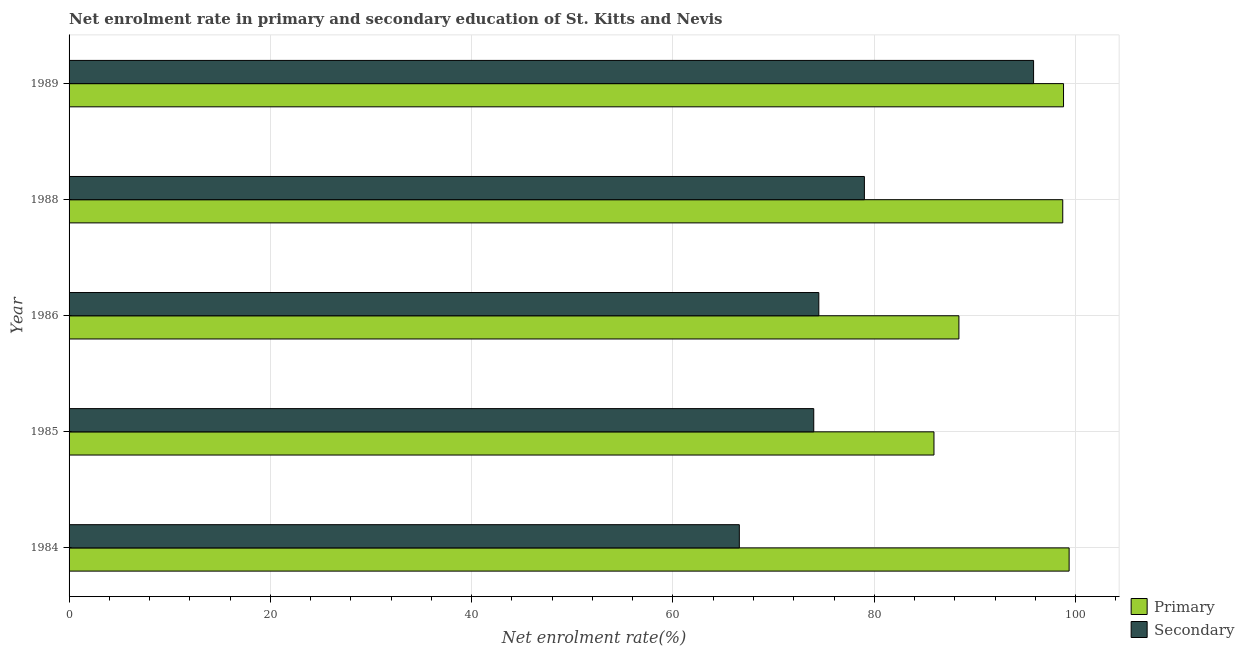How many groups of bars are there?
Offer a terse response. 5. Are the number of bars per tick equal to the number of legend labels?
Offer a very short reply. Yes. Are the number of bars on each tick of the Y-axis equal?
Provide a short and direct response. Yes. How many bars are there on the 2nd tick from the top?
Your response must be concise. 2. In how many cases, is the number of bars for a given year not equal to the number of legend labels?
Your response must be concise. 0. What is the enrollment rate in secondary education in 1986?
Your response must be concise. 74.49. Across all years, what is the maximum enrollment rate in primary education?
Make the answer very short. 99.36. Across all years, what is the minimum enrollment rate in primary education?
Keep it short and to the point. 85.93. What is the total enrollment rate in primary education in the graph?
Your answer should be compact. 471.24. What is the difference between the enrollment rate in secondary education in 1985 and that in 1986?
Provide a succinct answer. -0.5. What is the difference between the enrollment rate in primary education in 1985 and the enrollment rate in secondary education in 1989?
Provide a succinct answer. -9.9. What is the average enrollment rate in secondary education per year?
Offer a very short reply. 77.98. In the year 1984, what is the difference between the enrollment rate in primary education and enrollment rate in secondary education?
Offer a terse response. 32.77. In how many years, is the enrollment rate in secondary education greater than 32 %?
Your response must be concise. 5. What is the ratio of the enrollment rate in secondary education in 1986 to that in 1989?
Your response must be concise. 0.78. Is the enrollment rate in primary education in 1986 less than that in 1988?
Make the answer very short. Yes. Is the difference between the enrollment rate in secondary education in 1984 and 1988 greater than the difference between the enrollment rate in primary education in 1984 and 1988?
Your response must be concise. No. What is the difference between the highest and the second highest enrollment rate in secondary education?
Provide a short and direct response. 16.81. What is the difference between the highest and the lowest enrollment rate in secondary education?
Offer a very short reply. 29.24. In how many years, is the enrollment rate in secondary education greater than the average enrollment rate in secondary education taken over all years?
Your answer should be very brief. 2. What does the 2nd bar from the top in 1989 represents?
Make the answer very short. Primary. What does the 2nd bar from the bottom in 1989 represents?
Provide a succinct answer. Secondary. How many bars are there?
Ensure brevity in your answer.  10. Are all the bars in the graph horizontal?
Offer a terse response. Yes. How many years are there in the graph?
Provide a succinct answer. 5. Does the graph contain any zero values?
Provide a short and direct response. No. Does the graph contain grids?
Offer a very short reply. Yes. How many legend labels are there?
Provide a short and direct response. 2. What is the title of the graph?
Keep it short and to the point. Net enrolment rate in primary and secondary education of St. Kitts and Nevis. Does "Under-5(female)" appear as one of the legend labels in the graph?
Your answer should be very brief. No. What is the label or title of the X-axis?
Provide a succinct answer. Net enrolment rate(%). What is the label or title of the Y-axis?
Provide a succinct answer. Year. What is the Net enrolment rate(%) in Primary in 1984?
Ensure brevity in your answer.  99.36. What is the Net enrolment rate(%) of Secondary in 1984?
Give a very brief answer. 66.59. What is the Net enrolment rate(%) of Primary in 1985?
Your answer should be compact. 85.93. What is the Net enrolment rate(%) in Secondary in 1985?
Offer a terse response. 73.99. What is the Net enrolment rate(%) in Primary in 1986?
Offer a very short reply. 88.41. What is the Net enrolment rate(%) in Secondary in 1986?
Make the answer very short. 74.49. What is the Net enrolment rate(%) in Primary in 1988?
Provide a succinct answer. 98.73. What is the Net enrolment rate(%) in Secondary in 1988?
Give a very brief answer. 79.02. What is the Net enrolment rate(%) in Primary in 1989?
Ensure brevity in your answer.  98.81. What is the Net enrolment rate(%) in Secondary in 1989?
Give a very brief answer. 95.83. Across all years, what is the maximum Net enrolment rate(%) in Primary?
Give a very brief answer. 99.36. Across all years, what is the maximum Net enrolment rate(%) of Secondary?
Offer a very short reply. 95.83. Across all years, what is the minimum Net enrolment rate(%) in Primary?
Keep it short and to the point. 85.93. Across all years, what is the minimum Net enrolment rate(%) in Secondary?
Ensure brevity in your answer.  66.59. What is the total Net enrolment rate(%) in Primary in the graph?
Your answer should be compact. 471.24. What is the total Net enrolment rate(%) in Secondary in the graph?
Keep it short and to the point. 389.92. What is the difference between the Net enrolment rate(%) of Primary in 1984 and that in 1985?
Make the answer very short. 13.43. What is the difference between the Net enrolment rate(%) in Secondary in 1984 and that in 1985?
Give a very brief answer. -7.39. What is the difference between the Net enrolment rate(%) of Primary in 1984 and that in 1986?
Keep it short and to the point. 10.95. What is the difference between the Net enrolment rate(%) of Secondary in 1984 and that in 1986?
Keep it short and to the point. -7.9. What is the difference between the Net enrolment rate(%) of Primary in 1984 and that in 1988?
Keep it short and to the point. 0.63. What is the difference between the Net enrolment rate(%) in Secondary in 1984 and that in 1988?
Ensure brevity in your answer.  -12.43. What is the difference between the Net enrolment rate(%) in Primary in 1984 and that in 1989?
Make the answer very short. 0.56. What is the difference between the Net enrolment rate(%) of Secondary in 1984 and that in 1989?
Your answer should be very brief. -29.24. What is the difference between the Net enrolment rate(%) in Primary in 1985 and that in 1986?
Ensure brevity in your answer.  -2.48. What is the difference between the Net enrolment rate(%) of Secondary in 1985 and that in 1986?
Your answer should be compact. -0.5. What is the difference between the Net enrolment rate(%) of Primary in 1985 and that in 1988?
Offer a very short reply. -12.79. What is the difference between the Net enrolment rate(%) of Secondary in 1985 and that in 1988?
Provide a succinct answer. -5.03. What is the difference between the Net enrolment rate(%) in Primary in 1985 and that in 1989?
Make the answer very short. -12.87. What is the difference between the Net enrolment rate(%) of Secondary in 1985 and that in 1989?
Keep it short and to the point. -21.84. What is the difference between the Net enrolment rate(%) in Primary in 1986 and that in 1988?
Your answer should be very brief. -10.32. What is the difference between the Net enrolment rate(%) of Secondary in 1986 and that in 1988?
Keep it short and to the point. -4.53. What is the difference between the Net enrolment rate(%) of Primary in 1986 and that in 1989?
Offer a terse response. -10.4. What is the difference between the Net enrolment rate(%) of Secondary in 1986 and that in 1989?
Offer a very short reply. -21.34. What is the difference between the Net enrolment rate(%) of Primary in 1988 and that in 1989?
Your response must be concise. -0.08. What is the difference between the Net enrolment rate(%) of Secondary in 1988 and that in 1989?
Make the answer very short. -16.81. What is the difference between the Net enrolment rate(%) of Primary in 1984 and the Net enrolment rate(%) of Secondary in 1985?
Offer a terse response. 25.37. What is the difference between the Net enrolment rate(%) of Primary in 1984 and the Net enrolment rate(%) of Secondary in 1986?
Your response must be concise. 24.87. What is the difference between the Net enrolment rate(%) of Primary in 1984 and the Net enrolment rate(%) of Secondary in 1988?
Provide a succinct answer. 20.34. What is the difference between the Net enrolment rate(%) in Primary in 1984 and the Net enrolment rate(%) in Secondary in 1989?
Make the answer very short. 3.53. What is the difference between the Net enrolment rate(%) of Primary in 1985 and the Net enrolment rate(%) of Secondary in 1986?
Your response must be concise. 11.44. What is the difference between the Net enrolment rate(%) of Primary in 1985 and the Net enrolment rate(%) of Secondary in 1988?
Your answer should be very brief. 6.91. What is the difference between the Net enrolment rate(%) of Primary in 1985 and the Net enrolment rate(%) of Secondary in 1989?
Your answer should be very brief. -9.9. What is the difference between the Net enrolment rate(%) of Primary in 1986 and the Net enrolment rate(%) of Secondary in 1988?
Ensure brevity in your answer.  9.39. What is the difference between the Net enrolment rate(%) of Primary in 1986 and the Net enrolment rate(%) of Secondary in 1989?
Ensure brevity in your answer.  -7.42. What is the difference between the Net enrolment rate(%) of Primary in 1988 and the Net enrolment rate(%) of Secondary in 1989?
Ensure brevity in your answer.  2.9. What is the average Net enrolment rate(%) of Primary per year?
Offer a terse response. 94.25. What is the average Net enrolment rate(%) of Secondary per year?
Give a very brief answer. 77.98. In the year 1984, what is the difference between the Net enrolment rate(%) in Primary and Net enrolment rate(%) in Secondary?
Make the answer very short. 32.77. In the year 1985, what is the difference between the Net enrolment rate(%) of Primary and Net enrolment rate(%) of Secondary?
Your answer should be compact. 11.94. In the year 1986, what is the difference between the Net enrolment rate(%) of Primary and Net enrolment rate(%) of Secondary?
Your answer should be very brief. 13.92. In the year 1988, what is the difference between the Net enrolment rate(%) in Primary and Net enrolment rate(%) in Secondary?
Give a very brief answer. 19.71. In the year 1989, what is the difference between the Net enrolment rate(%) of Primary and Net enrolment rate(%) of Secondary?
Make the answer very short. 2.98. What is the ratio of the Net enrolment rate(%) in Primary in 1984 to that in 1985?
Make the answer very short. 1.16. What is the ratio of the Net enrolment rate(%) in Secondary in 1984 to that in 1985?
Provide a succinct answer. 0.9. What is the ratio of the Net enrolment rate(%) in Primary in 1984 to that in 1986?
Provide a succinct answer. 1.12. What is the ratio of the Net enrolment rate(%) in Secondary in 1984 to that in 1986?
Provide a short and direct response. 0.89. What is the ratio of the Net enrolment rate(%) of Primary in 1984 to that in 1988?
Your answer should be compact. 1.01. What is the ratio of the Net enrolment rate(%) of Secondary in 1984 to that in 1988?
Keep it short and to the point. 0.84. What is the ratio of the Net enrolment rate(%) in Primary in 1984 to that in 1989?
Your answer should be very brief. 1.01. What is the ratio of the Net enrolment rate(%) of Secondary in 1984 to that in 1989?
Provide a short and direct response. 0.69. What is the ratio of the Net enrolment rate(%) of Primary in 1985 to that in 1986?
Your response must be concise. 0.97. What is the ratio of the Net enrolment rate(%) of Secondary in 1985 to that in 1986?
Offer a terse response. 0.99. What is the ratio of the Net enrolment rate(%) in Primary in 1985 to that in 1988?
Your answer should be very brief. 0.87. What is the ratio of the Net enrolment rate(%) of Secondary in 1985 to that in 1988?
Offer a terse response. 0.94. What is the ratio of the Net enrolment rate(%) of Primary in 1985 to that in 1989?
Give a very brief answer. 0.87. What is the ratio of the Net enrolment rate(%) in Secondary in 1985 to that in 1989?
Your answer should be very brief. 0.77. What is the ratio of the Net enrolment rate(%) in Primary in 1986 to that in 1988?
Ensure brevity in your answer.  0.9. What is the ratio of the Net enrolment rate(%) in Secondary in 1986 to that in 1988?
Keep it short and to the point. 0.94. What is the ratio of the Net enrolment rate(%) in Primary in 1986 to that in 1989?
Give a very brief answer. 0.89. What is the ratio of the Net enrolment rate(%) in Secondary in 1986 to that in 1989?
Make the answer very short. 0.78. What is the ratio of the Net enrolment rate(%) in Primary in 1988 to that in 1989?
Offer a very short reply. 1. What is the ratio of the Net enrolment rate(%) of Secondary in 1988 to that in 1989?
Your response must be concise. 0.82. What is the difference between the highest and the second highest Net enrolment rate(%) in Primary?
Give a very brief answer. 0.56. What is the difference between the highest and the second highest Net enrolment rate(%) of Secondary?
Give a very brief answer. 16.81. What is the difference between the highest and the lowest Net enrolment rate(%) of Primary?
Your answer should be very brief. 13.43. What is the difference between the highest and the lowest Net enrolment rate(%) of Secondary?
Your answer should be very brief. 29.24. 